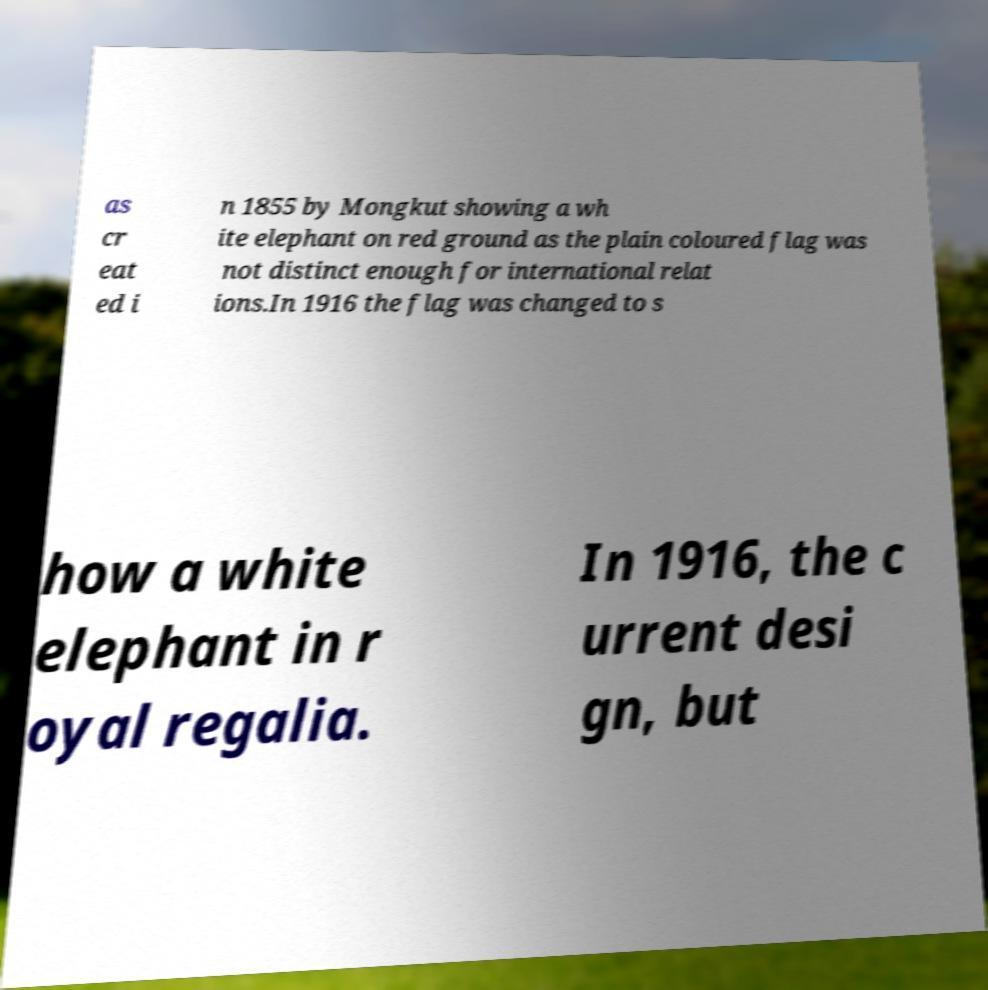For documentation purposes, I need the text within this image transcribed. Could you provide that? as cr eat ed i n 1855 by Mongkut showing a wh ite elephant on red ground as the plain coloured flag was not distinct enough for international relat ions.In 1916 the flag was changed to s how a white elephant in r oyal regalia. In 1916, the c urrent desi gn, but 